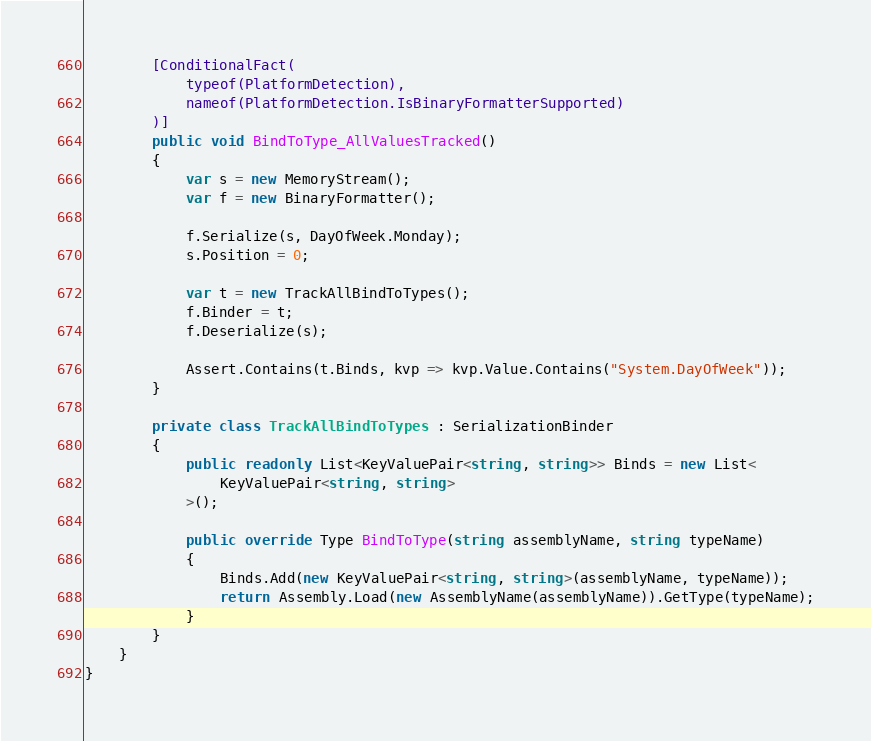Convert code to text. <code><loc_0><loc_0><loc_500><loc_500><_C#_>        [ConditionalFact(
            typeof(PlatformDetection),
            nameof(PlatformDetection.IsBinaryFormatterSupported)
        )]
        public void BindToType_AllValuesTracked()
        {
            var s = new MemoryStream();
            var f = new BinaryFormatter();

            f.Serialize(s, DayOfWeek.Monday);
            s.Position = 0;

            var t = new TrackAllBindToTypes();
            f.Binder = t;
            f.Deserialize(s);

            Assert.Contains(t.Binds, kvp => kvp.Value.Contains("System.DayOfWeek"));
        }

        private class TrackAllBindToTypes : SerializationBinder
        {
            public readonly List<KeyValuePair<string, string>> Binds = new List<
                KeyValuePair<string, string>
            >();

            public override Type BindToType(string assemblyName, string typeName)
            {
                Binds.Add(new KeyValuePair<string, string>(assemblyName, typeName));
                return Assembly.Load(new AssemblyName(assemblyName)).GetType(typeName);
            }
        }
    }
}
</code> 